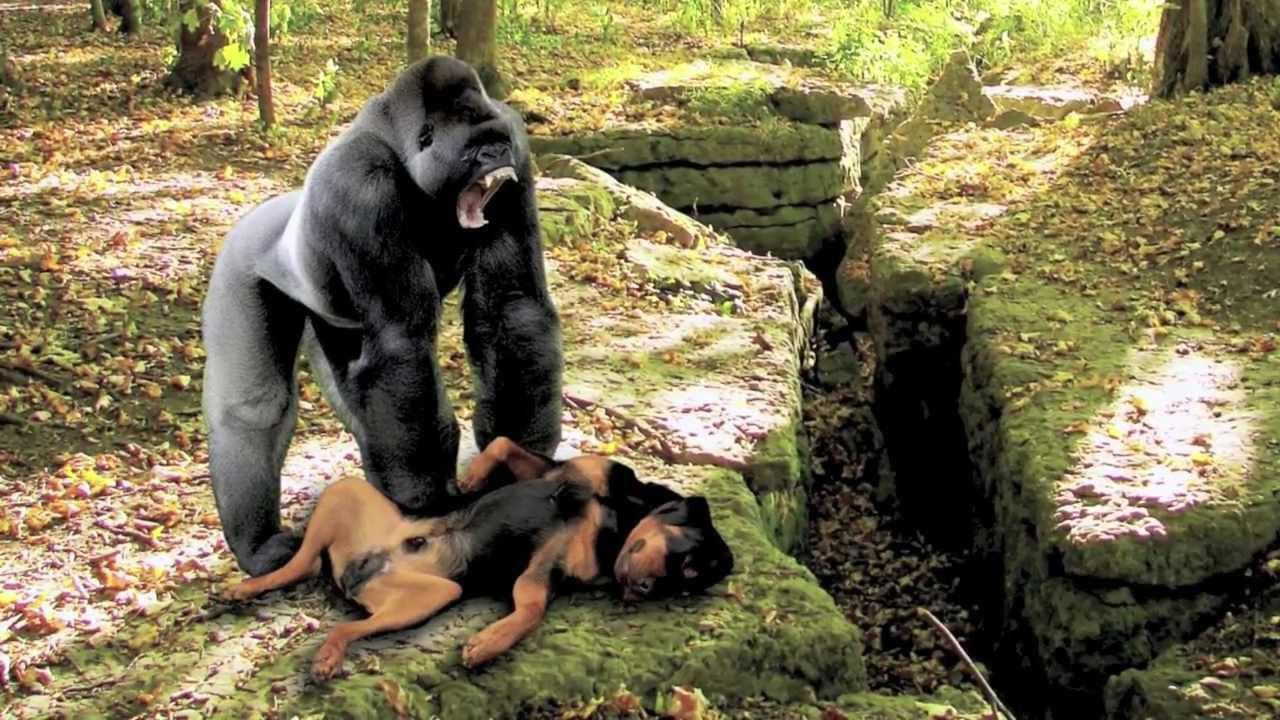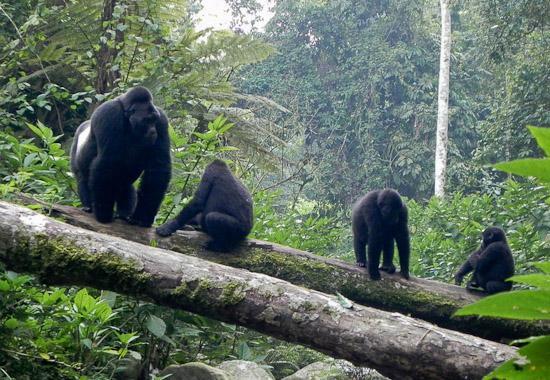The first image is the image on the left, the second image is the image on the right. Considering the images on both sides, is "The left image contains a human interacting with a gorilla." valid? Answer yes or no. No. 